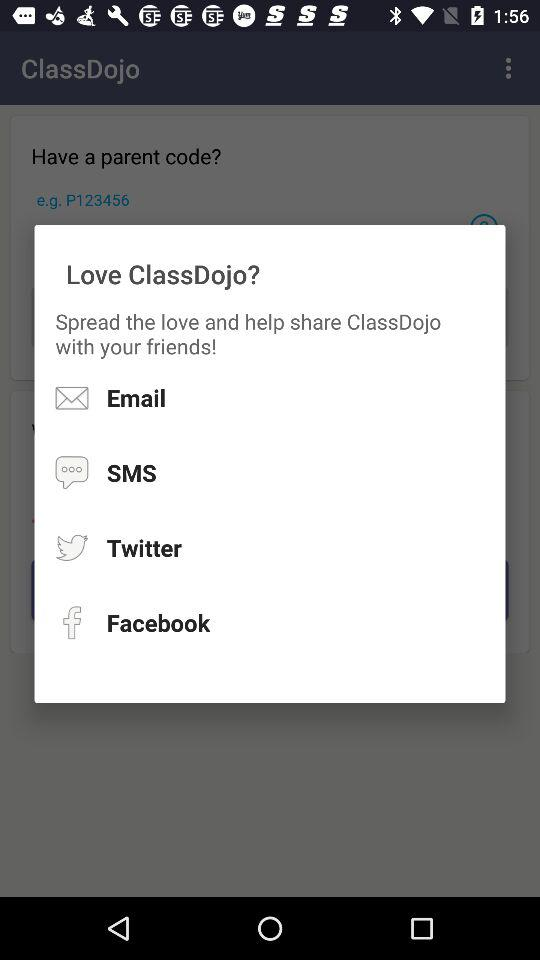Through what applications can we share the "Love ClassDojo"? You can share it through "Twitter" and "Facebook". 